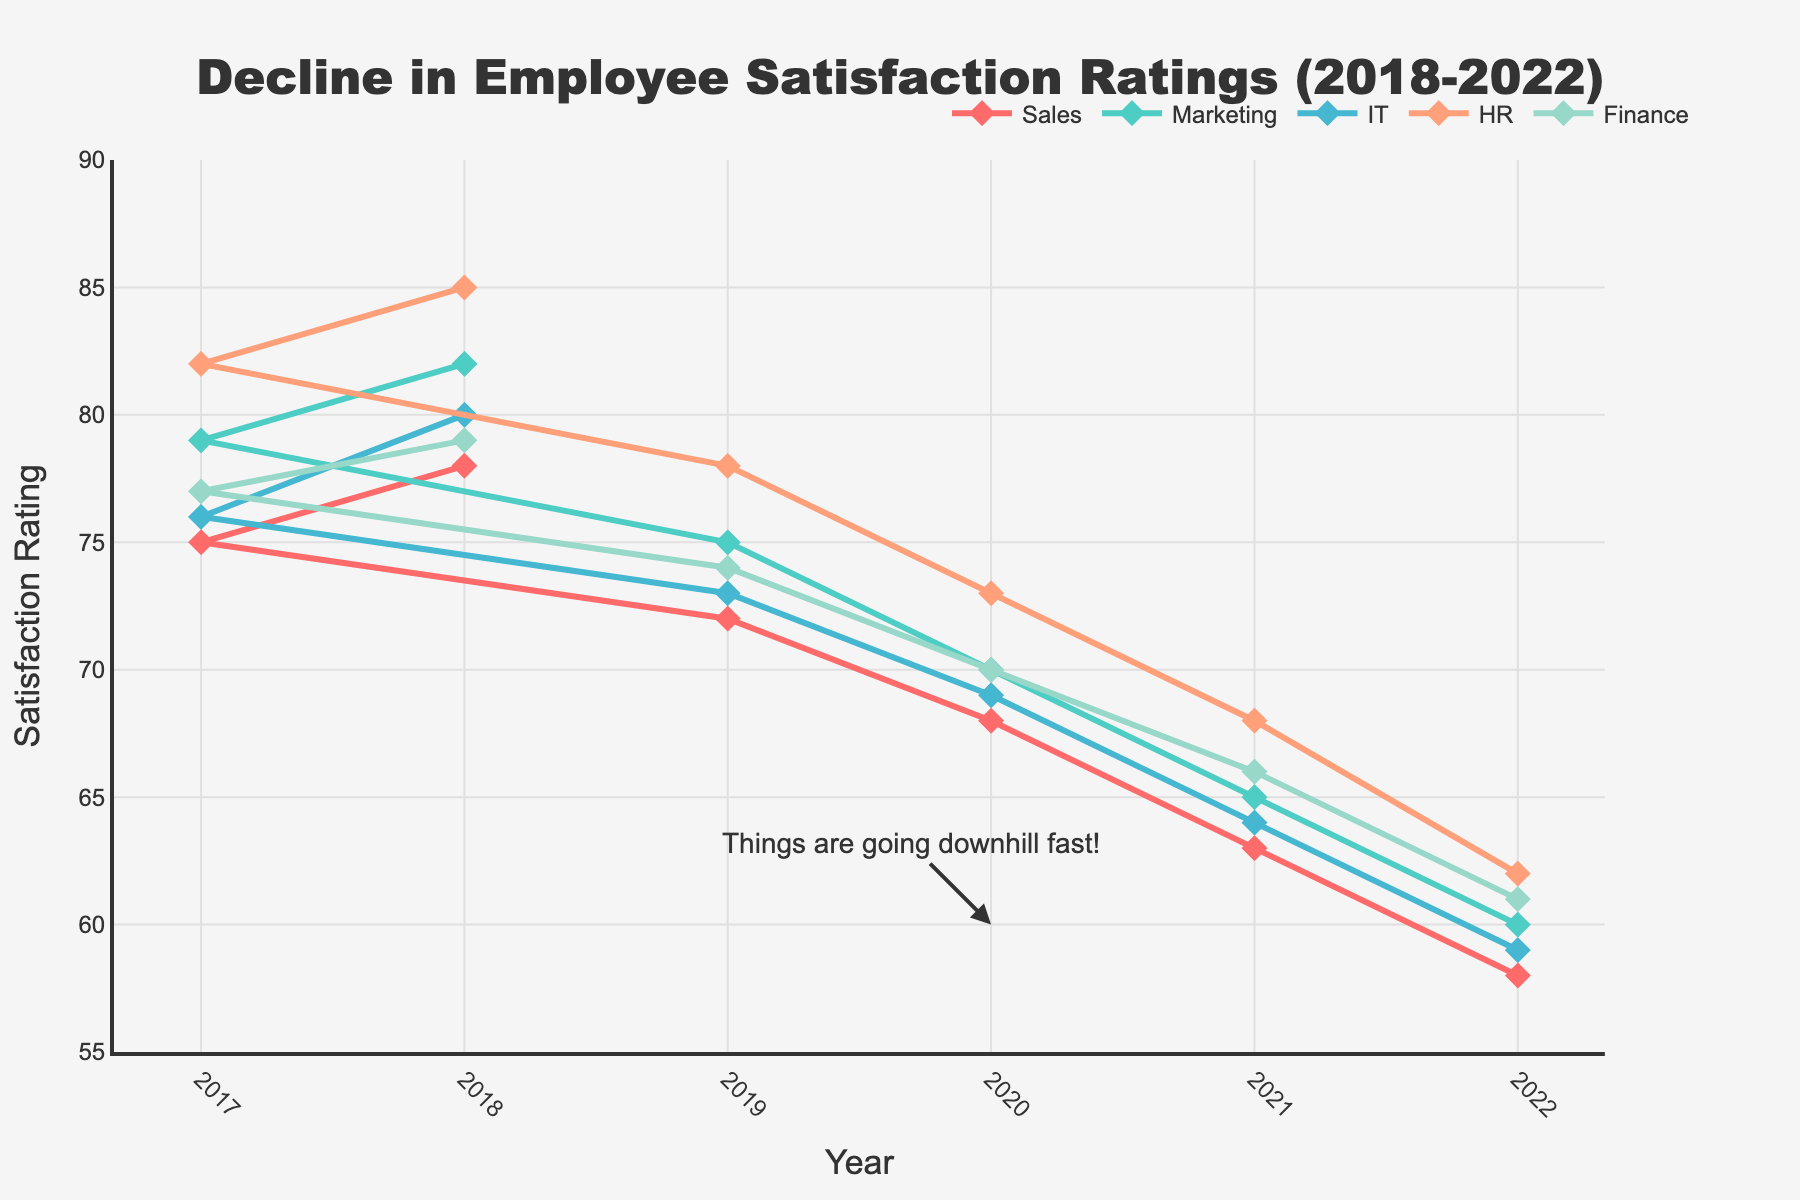Which department had the sharpest decline in satisfaction ratings from 2018 to 2022? By examining the line chart, identify the department with the steepest curve downward from 2018 to 2022. The HR department drops from 85 to 62, which is a decrease of 23 points, the largest among all departments.
Answer: HR Between 2019 and 2020, which department had the smallest decrease in satisfaction ratings? Compare the slopes of the lines for each department between the years 2019 and 2020. The Marketing department's ratings dropped from 70 to 68, showing the smallest decrease of 2 points.
Answer: Marketing What is the average satisfaction rating of the IT department across all years? Sum the IT department ratings for all years and divide by the number of years: (80 + 76 + 73 + 69 + 64 + 59) / 6 = 421 / 6 = 70.17.
Answer: 70.17 Which year showed the most significant drop in overall satisfaction across all departments? Calculate the decline for each year by summing up the differences across all departments and compare. The year 2020 shows a significant overall decrease, especially visible in the sharp downward trend of all lines from 2019 to 2020.
Answer: 2020 In 2022, which department had the highest satisfaction rating? Look at the endpoints of each line chart at the year 2022 and determine which line is at the highest position. The HR department, with a rating of 62, has the highest satisfaction in 2022.
Answer: HR How much did the Sales department's satisfaction rating change from 2018 to 2020? Subtract the 2020 rating from the 2018 rating for the Sales department: 78 (2018) - 68 (2020) = 10.
Answer: 10 What is the trend direction of the Finance department's satisfaction rating from 2018 to 2022? Observe the overall direction of the line representing the Finance department from 2018 to 2022, moving consistently downward from 79 to 61.
Answer: Downward Which two departments had almost parallel lines from 2019 to 2022, indicating similar trends in satisfaction ratings? Identify lines that maintain a parallel or near-parallel position on the chart from 2019 to 2022. The lines for Sales and IT are almost parallel in this period.
Answer: Sales and IT 